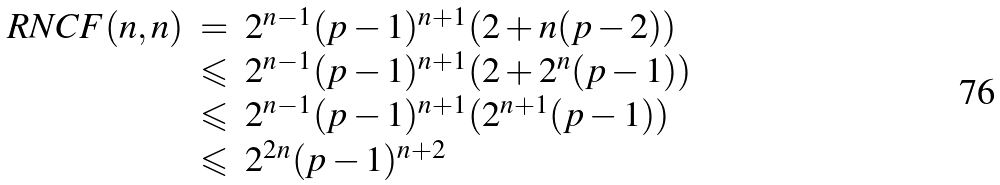<formula> <loc_0><loc_0><loc_500><loc_500>\begin{array} { l c l } R N C F ( n , n ) & = & 2 ^ { n - 1 } ( p - 1 ) ^ { n + 1 } ( 2 + n ( p - 2 ) ) \\ & \leqslant & 2 ^ { n - 1 } ( p - 1 ) ^ { n + 1 } ( 2 + 2 ^ { n } ( p - 1 ) ) \\ & \leqslant & 2 ^ { n - 1 } ( p - 1 ) ^ { n + 1 } ( 2 ^ { n + 1 } ( p - 1 ) ) \\ & \leqslant & 2 ^ { 2 n } ( p - 1 ) ^ { n + 2 } \end{array}</formula> 